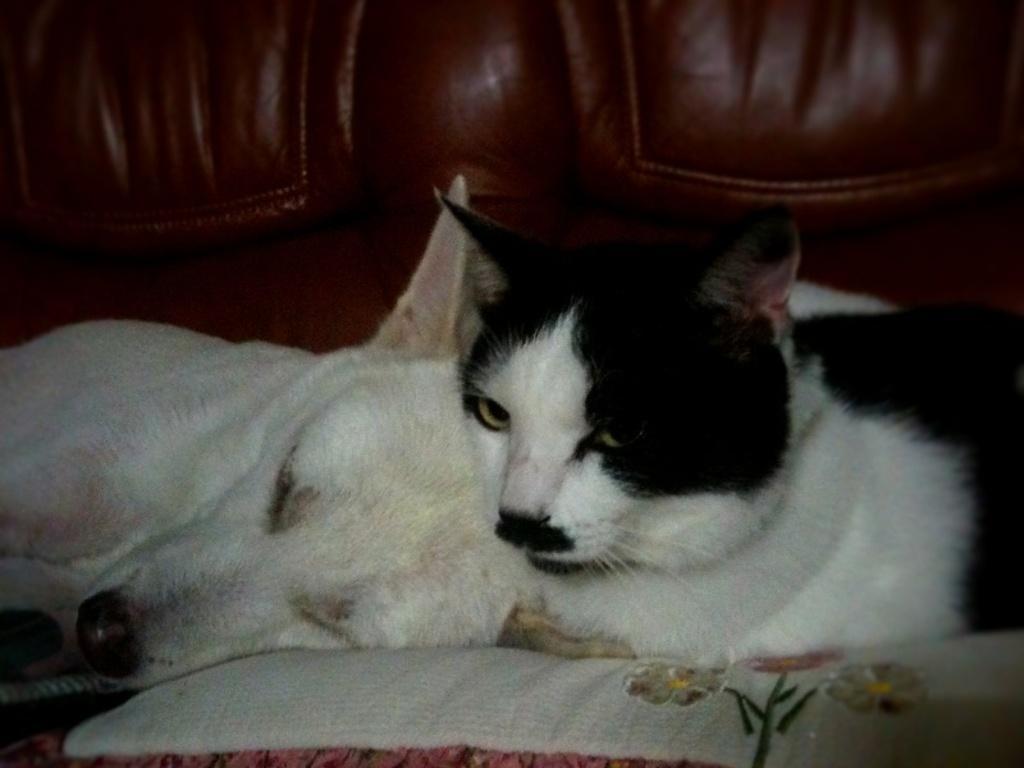Please provide a concise description of this image. In this picture there is a couch, on the couch there is a dog and a cat. 